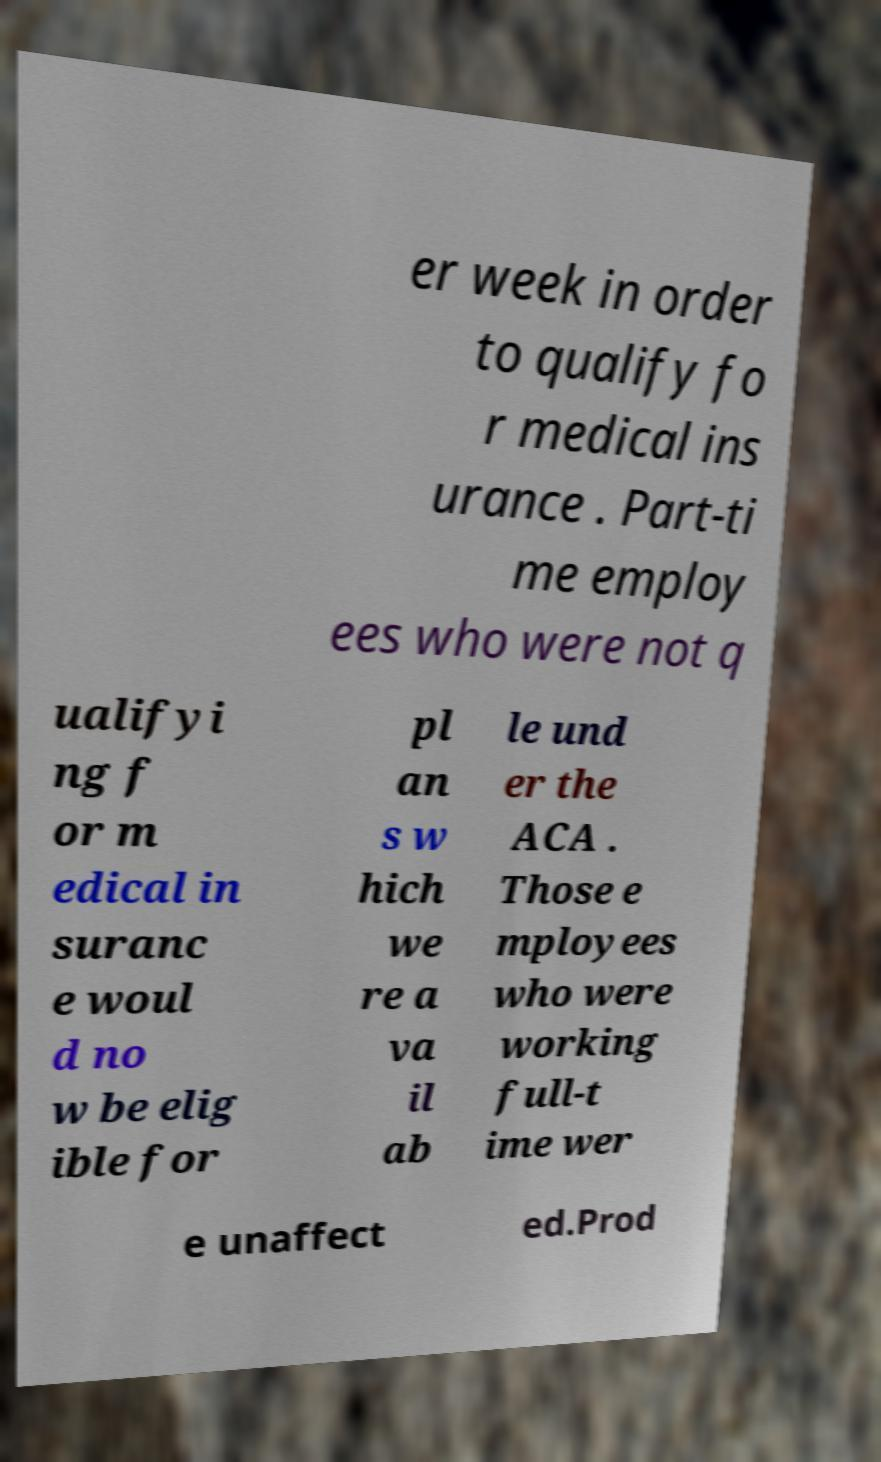I need the written content from this picture converted into text. Can you do that? er week in order to qualify fo r medical ins urance . Part-ti me employ ees who were not q ualifyi ng f or m edical in suranc e woul d no w be elig ible for pl an s w hich we re a va il ab le und er the ACA . Those e mployees who were working full-t ime wer e unaffect ed.Prod 